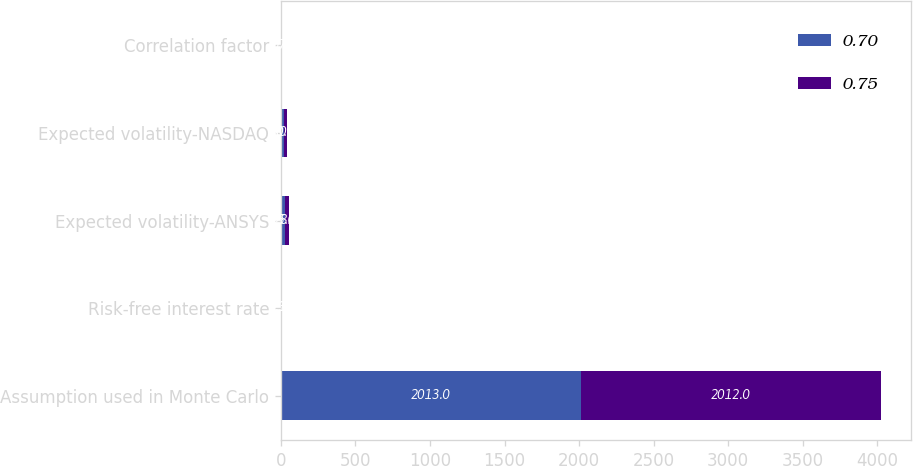Convert chart to OTSL. <chart><loc_0><loc_0><loc_500><loc_500><stacked_bar_chart><ecel><fcel>Assumption used in Monte Carlo<fcel>Risk-free interest rate<fcel>Expected volatility-ANSYS<fcel>Expected volatility-NASDAQ<fcel>Correlation factor<nl><fcel>0.7<fcel>2013<fcel>0.35<fcel>25<fcel>20<fcel>0.7<nl><fcel>0.75<fcel>2012<fcel>0.16<fcel>28<fcel>20<fcel>0.75<nl></chart> 